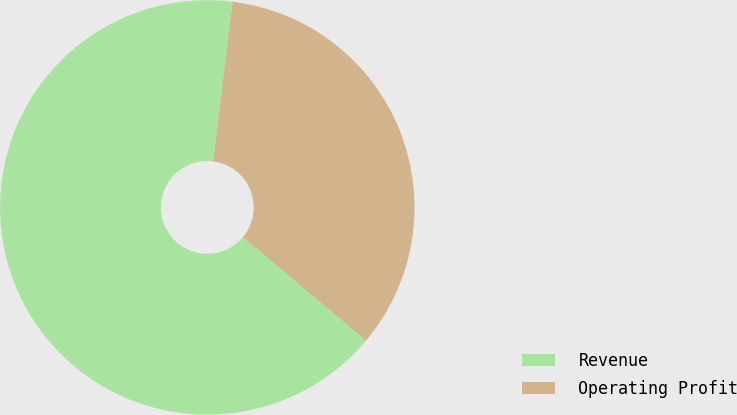<chart> <loc_0><loc_0><loc_500><loc_500><pie_chart><fcel>Revenue<fcel>Operating Profit<nl><fcel>65.83%<fcel>34.17%<nl></chart> 